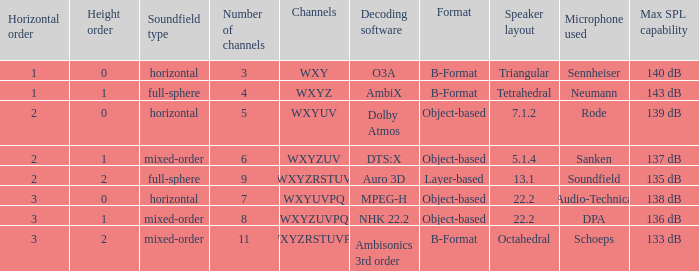If the channels include wxyzuv, what is the total number of channels? 6.0. 